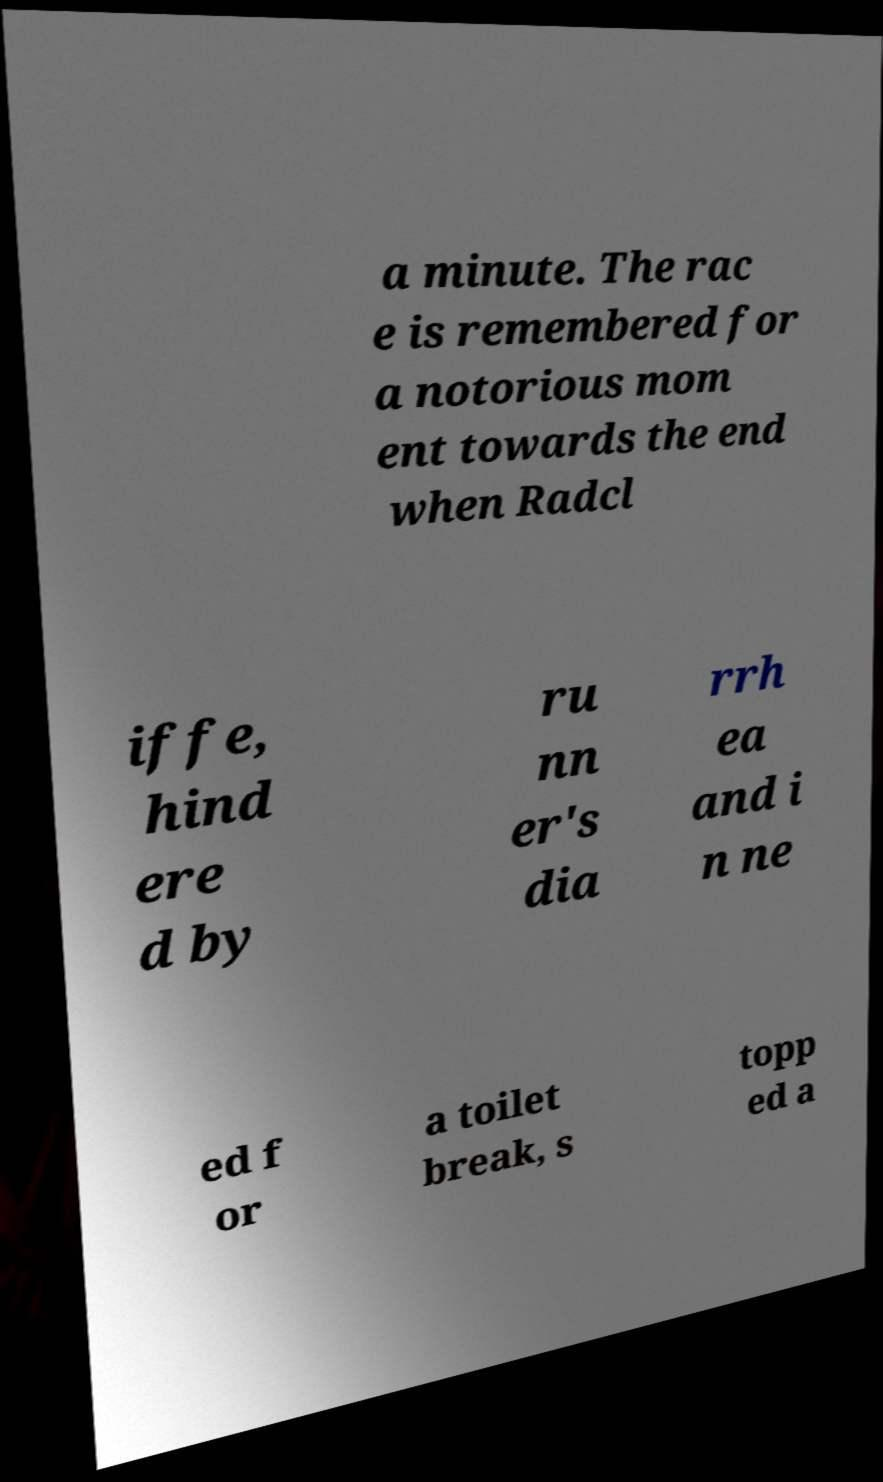There's text embedded in this image that I need extracted. Can you transcribe it verbatim? a minute. The rac e is remembered for a notorious mom ent towards the end when Radcl iffe, hind ere d by ru nn er's dia rrh ea and i n ne ed f or a toilet break, s topp ed a 